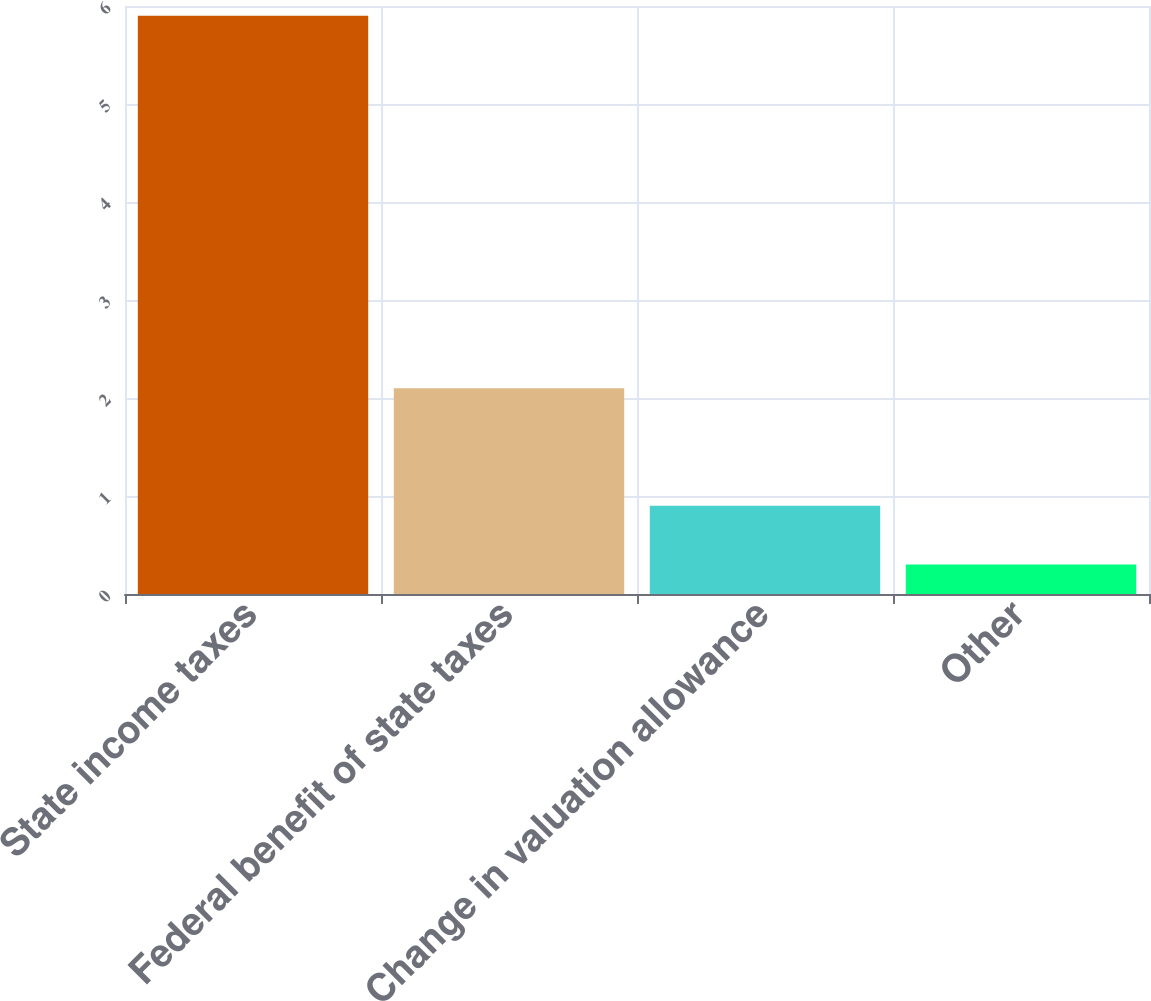Convert chart to OTSL. <chart><loc_0><loc_0><loc_500><loc_500><bar_chart><fcel>State income taxes<fcel>Federal benefit of state taxes<fcel>Change in valuation allowance<fcel>Other<nl><fcel>5.9<fcel>2.1<fcel>0.9<fcel>0.3<nl></chart> 